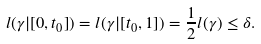<formula> <loc_0><loc_0><loc_500><loc_500>l ( \gamma | { [ 0 , t _ { 0 } ] } ) = l ( \gamma | { [ t _ { 0 } , 1 ] } ) = \frac { 1 } { 2 } l ( \gamma ) \leq \delta .</formula> 